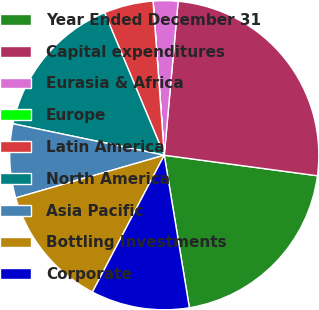<chart> <loc_0><loc_0><loc_500><loc_500><pie_chart><fcel>Year Ended December 31<fcel>Capital expenditures<fcel>Eurasia & Africa<fcel>Europe<fcel>Latin America<fcel>North America<fcel>Asia Pacific<fcel>Bottling Investments<fcel>Corporate<nl><fcel>20.28%<fcel>25.69%<fcel>2.58%<fcel>0.01%<fcel>5.15%<fcel>15.42%<fcel>7.72%<fcel>12.85%<fcel>10.29%<nl></chart> 